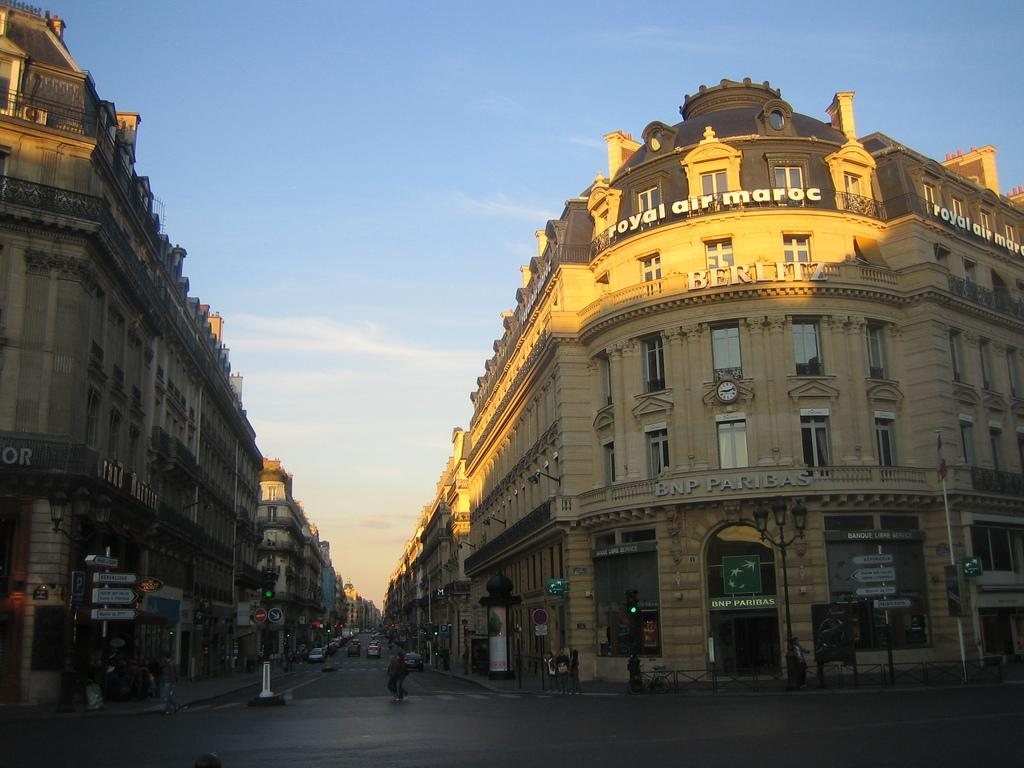What type of structures can be seen in the image? There are buildings in the image. What else can be seen on the roads in the image? Vehicles are present on the roads in the image. Are there any living beings visible in the image? Yes, there are people in the image. What are the poles used for in the image? The poles are likely used for supporting wires or signs in the image. What can be seen in the background of the image? The sky is visible in the background of the image. What type of meat is being cooked in the room shown in the image? There is no room or meat present in the image; it features buildings, vehicles, people, poles, and the sky. 